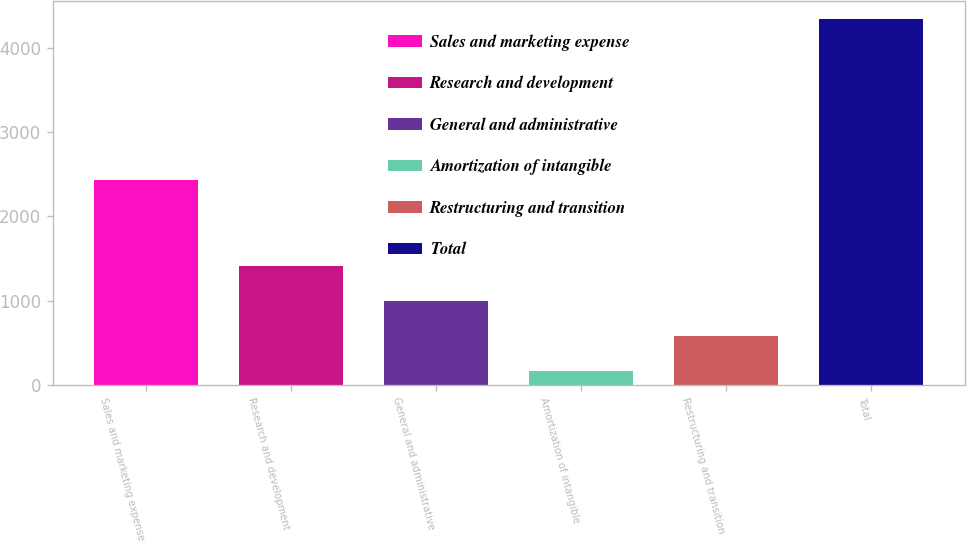Convert chart. <chart><loc_0><loc_0><loc_500><loc_500><bar_chart><fcel>Sales and marketing expense<fcel>Research and development<fcel>General and administrative<fcel>Amortization of intangible<fcel>Restructuring and transition<fcel>Total<nl><fcel>2435<fcel>1412.4<fcel>993.6<fcel>156<fcel>574.8<fcel>4344<nl></chart> 